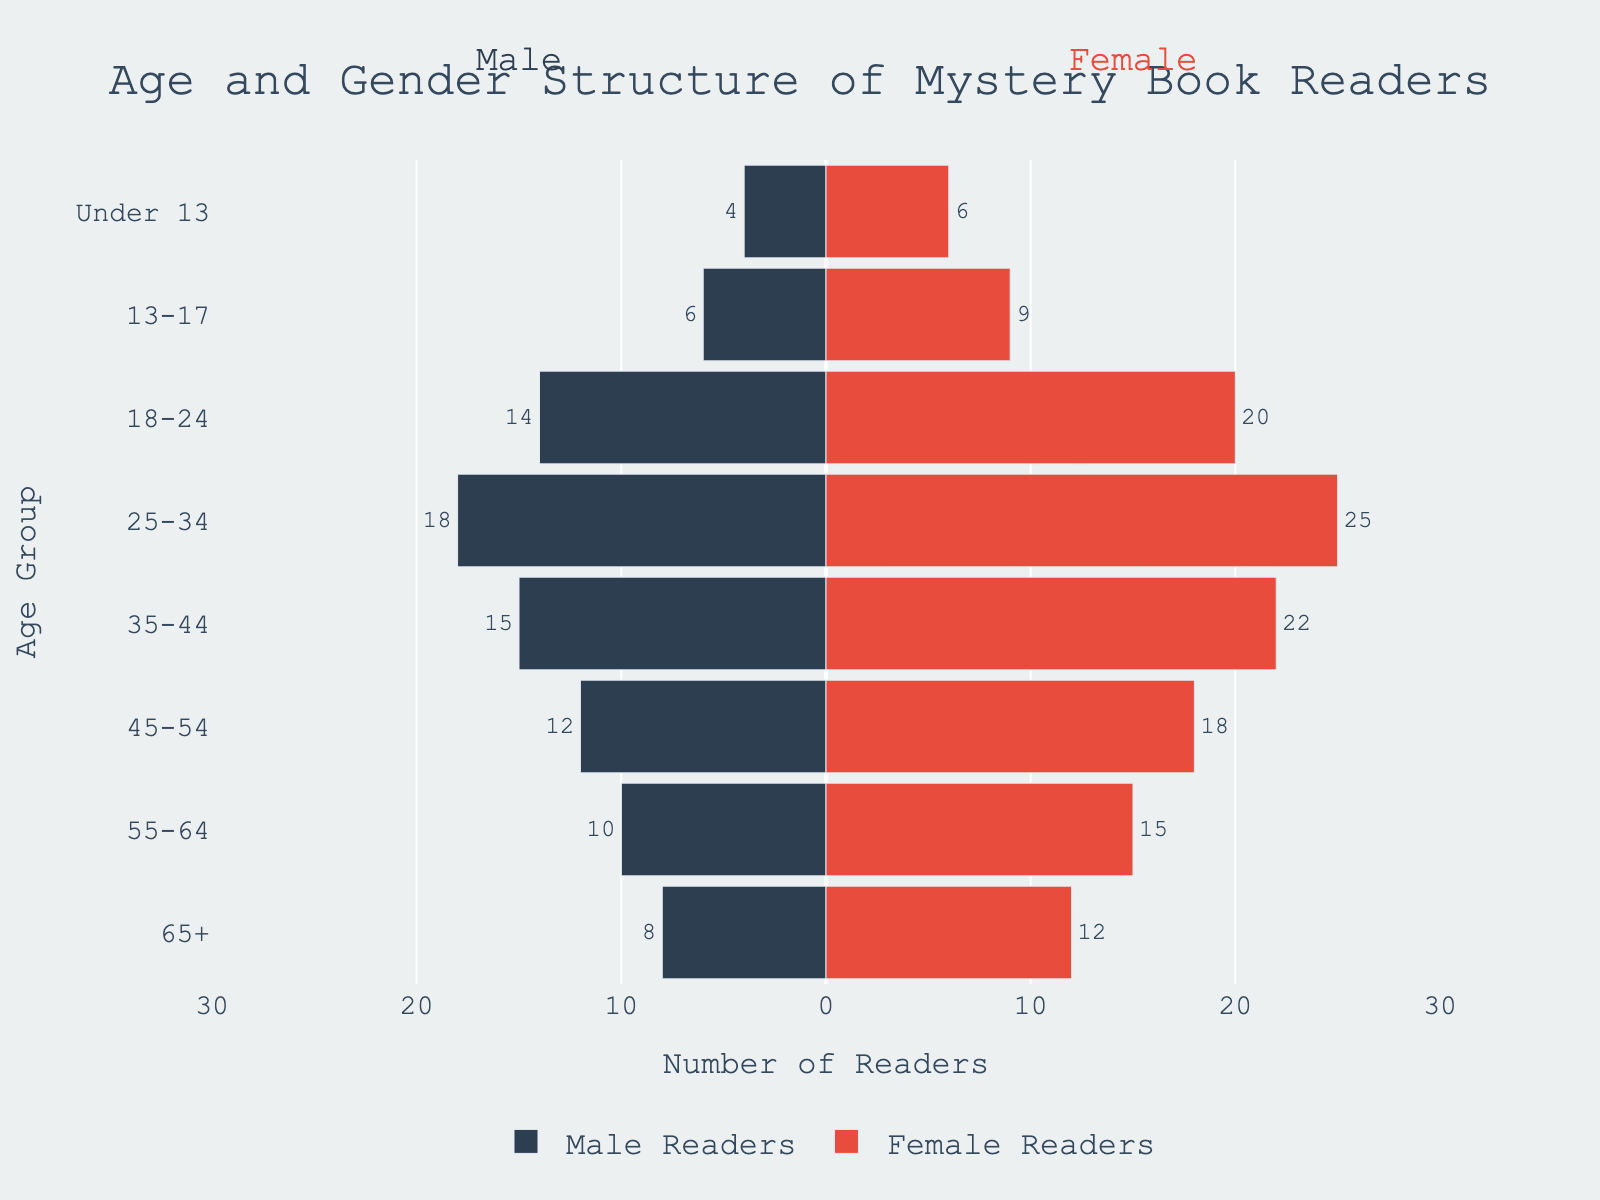What is the highest number of female readers in any age group? The figure shows the number of readers for each age group. The highest number of female readers is found in the 25-34 age group with 25 readers.
Answer: 25 How many total male readers are there across all age groups? By summing the number of male readers in each age group: 4 + 6 + 14 + 18 + 15 + 12 + 10 + 8 = 87.
Answer: 87 Which age group has more male readers compared to female readers? By comparing male and female readers for each age group, none of the groups have more male readers compared to female readers.
Answer: None What is the population difference between male and female readers in the 55-64 age group? In the 55-64 age group, there are 10 male readers and 15 female readers. The difference is 15 - 10 = 5 readers.
Answer: 5 Which age group has the lowest number of readers in total? By summing the male and female readers for each age group, the "Under 13" age group has the lowest total with 4 + 6 = 10 readers.
Answer: Under 13 What percentage of male readers are in the 25-34 age group out of total male readers? The total number of male readers is 87, and in the 25-34 age group, there are 18 male readers. The percentage is (18 / 87) * 100 ≈ 20.69%.
Answer: 20.69% In which age group do female readers significantly outnumber male readers? By comparing male and female readers, the 25-34 age group has the most significant difference with 18 male readers and 25 female readers; a difference of 7 readers.
Answer: 25-34 Comparing the teenage groups (13-17 and 18-24), which has a higher number of total readers? For the 13-17 group: 6 male + 9 female = 15. For the 18-24 group: 14 male + 20 female = 34. The 18-24 group is higher.
Answer: 18-24 What is the overall gender ratio of readers across all age groups? The total number of male readers is 87 and female readers is 127. The gender ratio (male:female) is 87:127 or approximately 0.68:1.
Answer: 0.68:1 